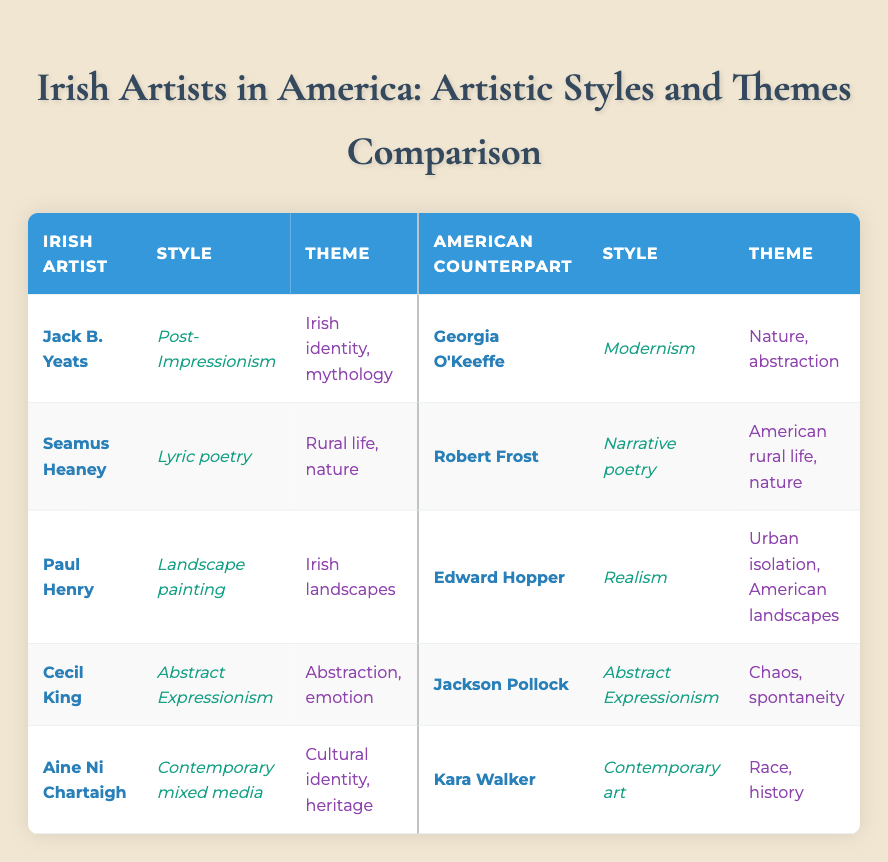What artistic style does Jack B. Yeats represent? Referring to the table, Jack B. Yeats is listed under the "Style" column in his row, which shows that he represents "Post-Impressionism."
Answer: Post-Impressionism Who is the American counterpart of Seamus Heaney? In the table, Seamus Heaney's row shows that his American counterpart is Robert Frost.
Answer: Robert Frost Do both Irish and American counterparts of Cecil King share the same artistic style? Cecil King and his American counterpart, Jackson Pollock, both fall under the "Abstract Expressionism" style, indicating that they share the same artistic style.
Answer: Yes What are the themes of Paul Henry's artwork? Looking at the table, under the "Theme" column for Paul Henry, it is stated that his themes are "Irish landscapes."
Answer: Irish landscapes Which Irish artist's theme focuses on cultural identity? The table shows that Aine Ni Chartaigh is the artist with a theme of "Cultural identity, heritage."
Answer: Aine Ni Chartaigh Which artistic style is associated with Georgia O'Keeffe? Georgia O'Keeffe's row indicates that her artistic style is "Modernism."
Answer: Modernism Is it true that Robert Frost's themes only focus on urban life? The table describes Robert Frost's themes as "American rural life, nature," which contradicts the idea that his focus is only on urban life.
Answer: No Compare the themes of Jack B. Yeats and Georgia O'Keeffe. According to the table, Jack B. Yeats explores themes of "Irish identity, mythology," while Georgia O'Keeffe focuses on "Nature, abstraction." This shows their themes come from different cultural focuses.
Answer: Different themes What is the commonality in style between Cecil King and Jackson Pollock? The table lists both of them under "Abstract Expressionism," indicating they share the same artistic style.
Answer: They share the same artistic style 